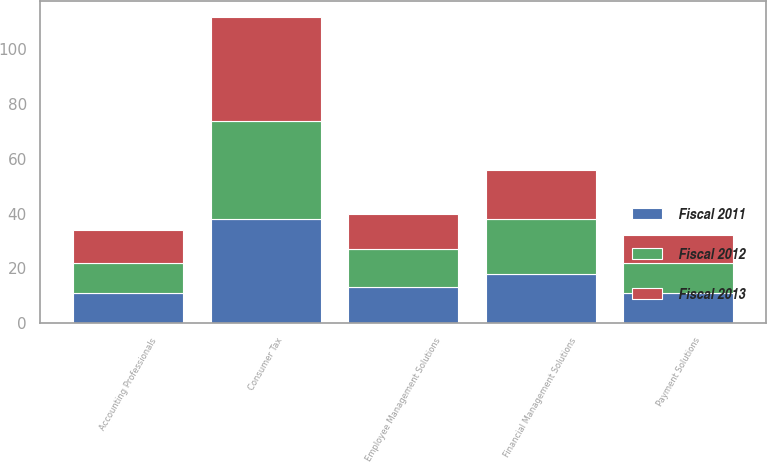Convert chart to OTSL. <chart><loc_0><loc_0><loc_500><loc_500><stacked_bar_chart><ecel><fcel>Financial Management Solutions<fcel>Employee Management Solutions<fcel>Payment Solutions<fcel>Consumer Tax<fcel>Accounting Professionals<nl><fcel>Fiscal 2012<fcel>20<fcel>14<fcel>11<fcel>36<fcel>11<nl><fcel>Fiscal 2011<fcel>18<fcel>13<fcel>11<fcel>38<fcel>11<nl><fcel>Fiscal 2013<fcel>18<fcel>13<fcel>10<fcel>38<fcel>12<nl></chart> 